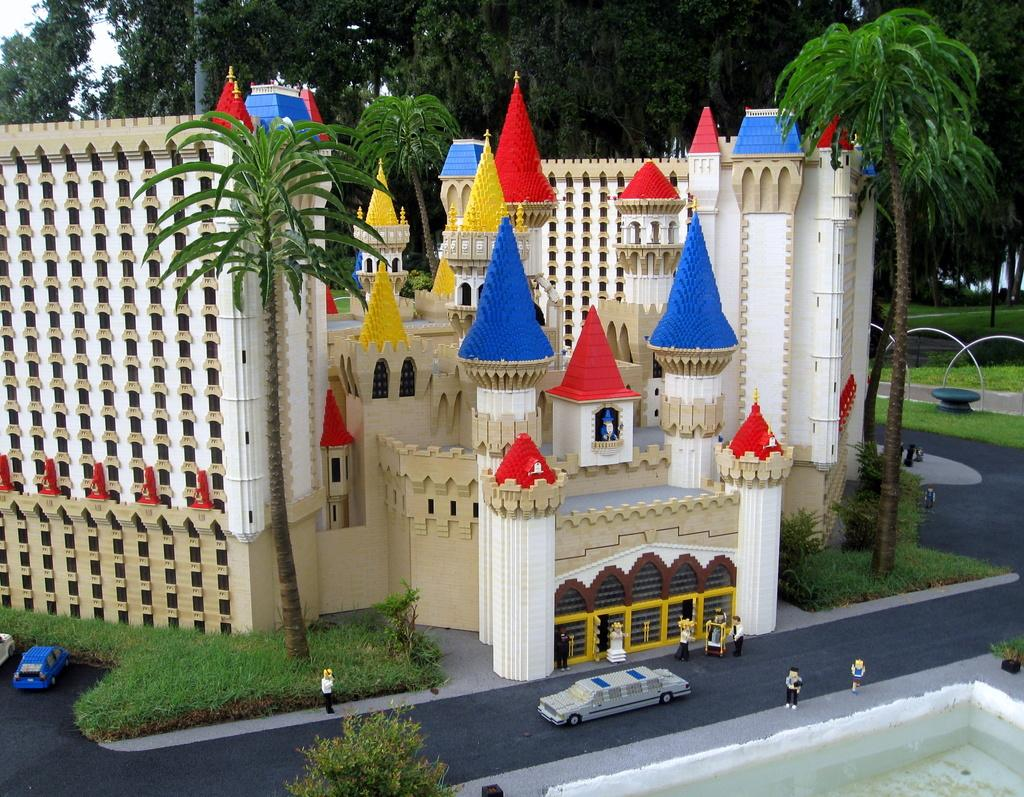What is the main object in the center of the image? There is a toy castle in the center of the image. What other object can be seen at the bottom side of the image? There is a car at the bottom side of the image. What type of natural elements are present at the top side of the image? There are trees at the top side of the image. Is there a volcano erupting in the background of the image? No, there is no volcano present in the image. Can you tell me how many dolls are sitting on the toy castle? There are no dolls present in the image; it only features a toy castle, a car, and trees. 